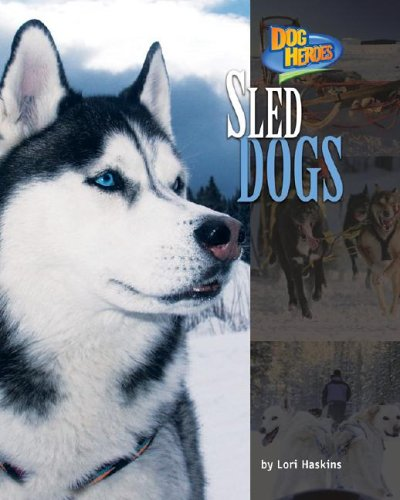Who is the author of this book?
Answer the question using a single word or phrase. Lori Haskins What is the title of this book? Sled Dogs (Dog Heroes) What type of book is this? Sports & Outdoors Is this a games related book? Yes Is this a recipe book? No 